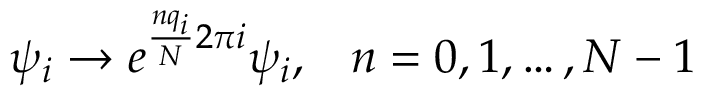<formula> <loc_0><loc_0><loc_500><loc_500>\psi _ { i } \to e ^ { \frac { n q _ { i } } { N } 2 \pi i } \psi _ { i } , \, n = 0 , 1 , \dots , N - 1</formula> 